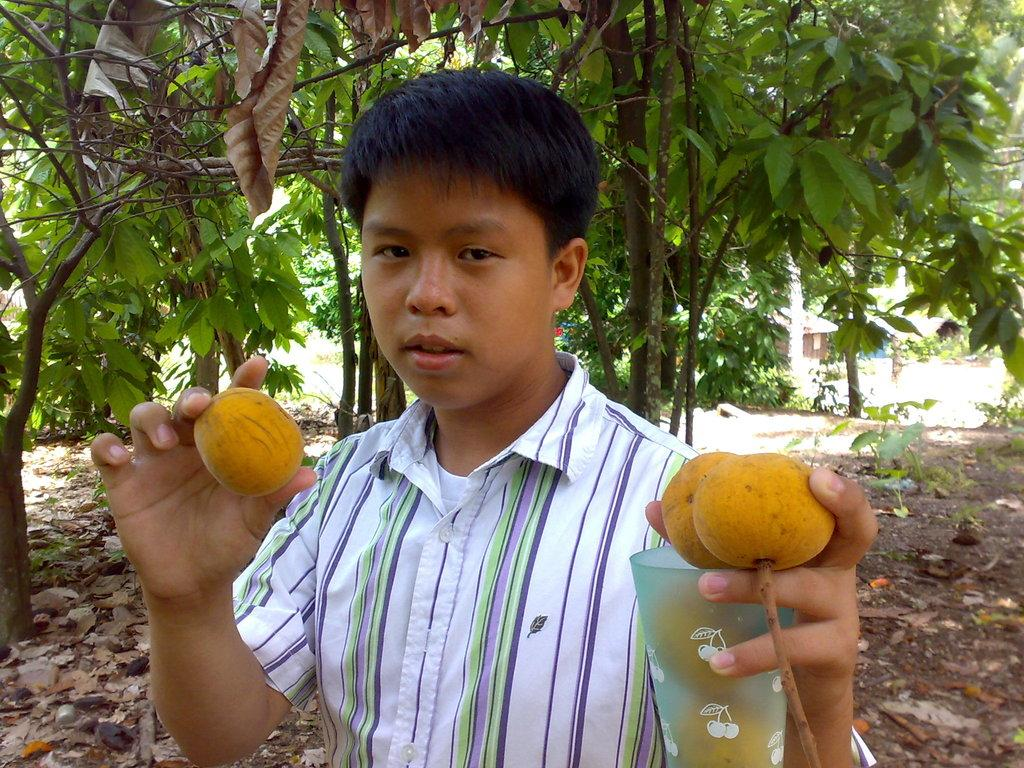What is the person in the image doing with the objects they are holding? The fact does not specify what the person is doing with the objects, so we cannot answer this definitively. What type of surface is visible under the person's feet in the image? There is ground with dry leaves in the image. What type of vegetation can be seen in the image? There are plants and trees in the image. What can be seen in the background of the image? There is a building in the background of the image. What type of church can be seen in the image? There is no church present in the image. How many stitches are visible on the person's clothing in the image? The fact does not mention any clothing or stitches, so we cannot answer this definitively. 